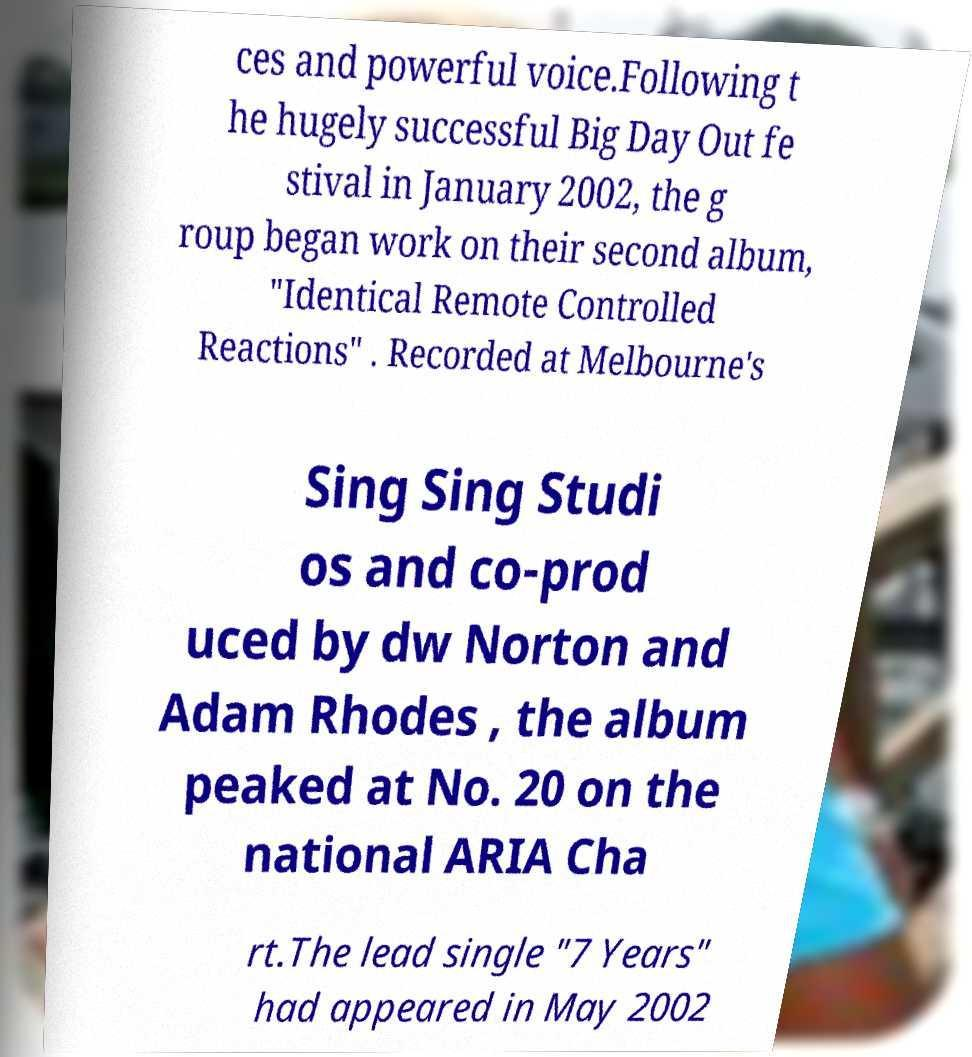For documentation purposes, I need the text within this image transcribed. Could you provide that? ces and powerful voice.Following t he hugely successful Big Day Out fe stival in January 2002, the g roup began work on their second album, "Identical Remote Controlled Reactions" . Recorded at Melbourne's Sing Sing Studi os and co-prod uced by dw Norton and Adam Rhodes , the album peaked at No. 20 on the national ARIA Cha rt.The lead single "7 Years" had appeared in May 2002 